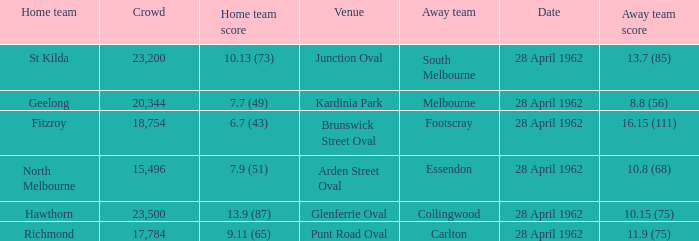At what venue did an away team score 10.15 (75)? Glenferrie Oval. 